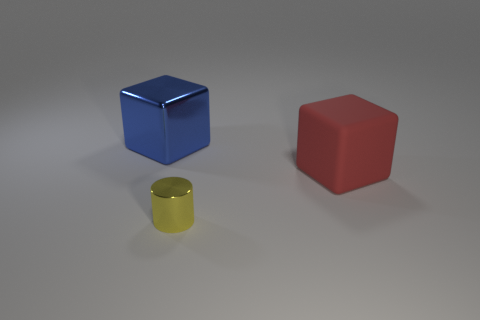Add 3 tiny green objects. How many objects exist? 6 Subtract all blocks. How many objects are left? 1 Add 2 tiny metal objects. How many tiny metal objects are left? 3 Add 3 green spheres. How many green spheres exist? 3 Subtract 0 brown cubes. How many objects are left? 3 Subtract all tiny metallic cylinders. Subtract all small red objects. How many objects are left? 2 